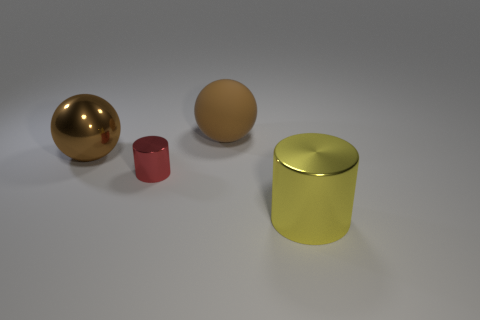Add 1 large metal balls. How many objects exist? 5 Subtract all red cylinders. How many cylinders are left? 1 Subtract 1 balls. How many balls are left? 1 Subtract 0 blue cylinders. How many objects are left? 4 Subtract all red cylinders. Subtract all cyan cubes. How many cylinders are left? 1 Subtract all green cubes. How many yellow cylinders are left? 1 Subtract all small purple matte objects. Subtract all cylinders. How many objects are left? 2 Add 3 large yellow things. How many large yellow things are left? 4 Add 1 big yellow metal cylinders. How many big yellow metal cylinders exist? 2 